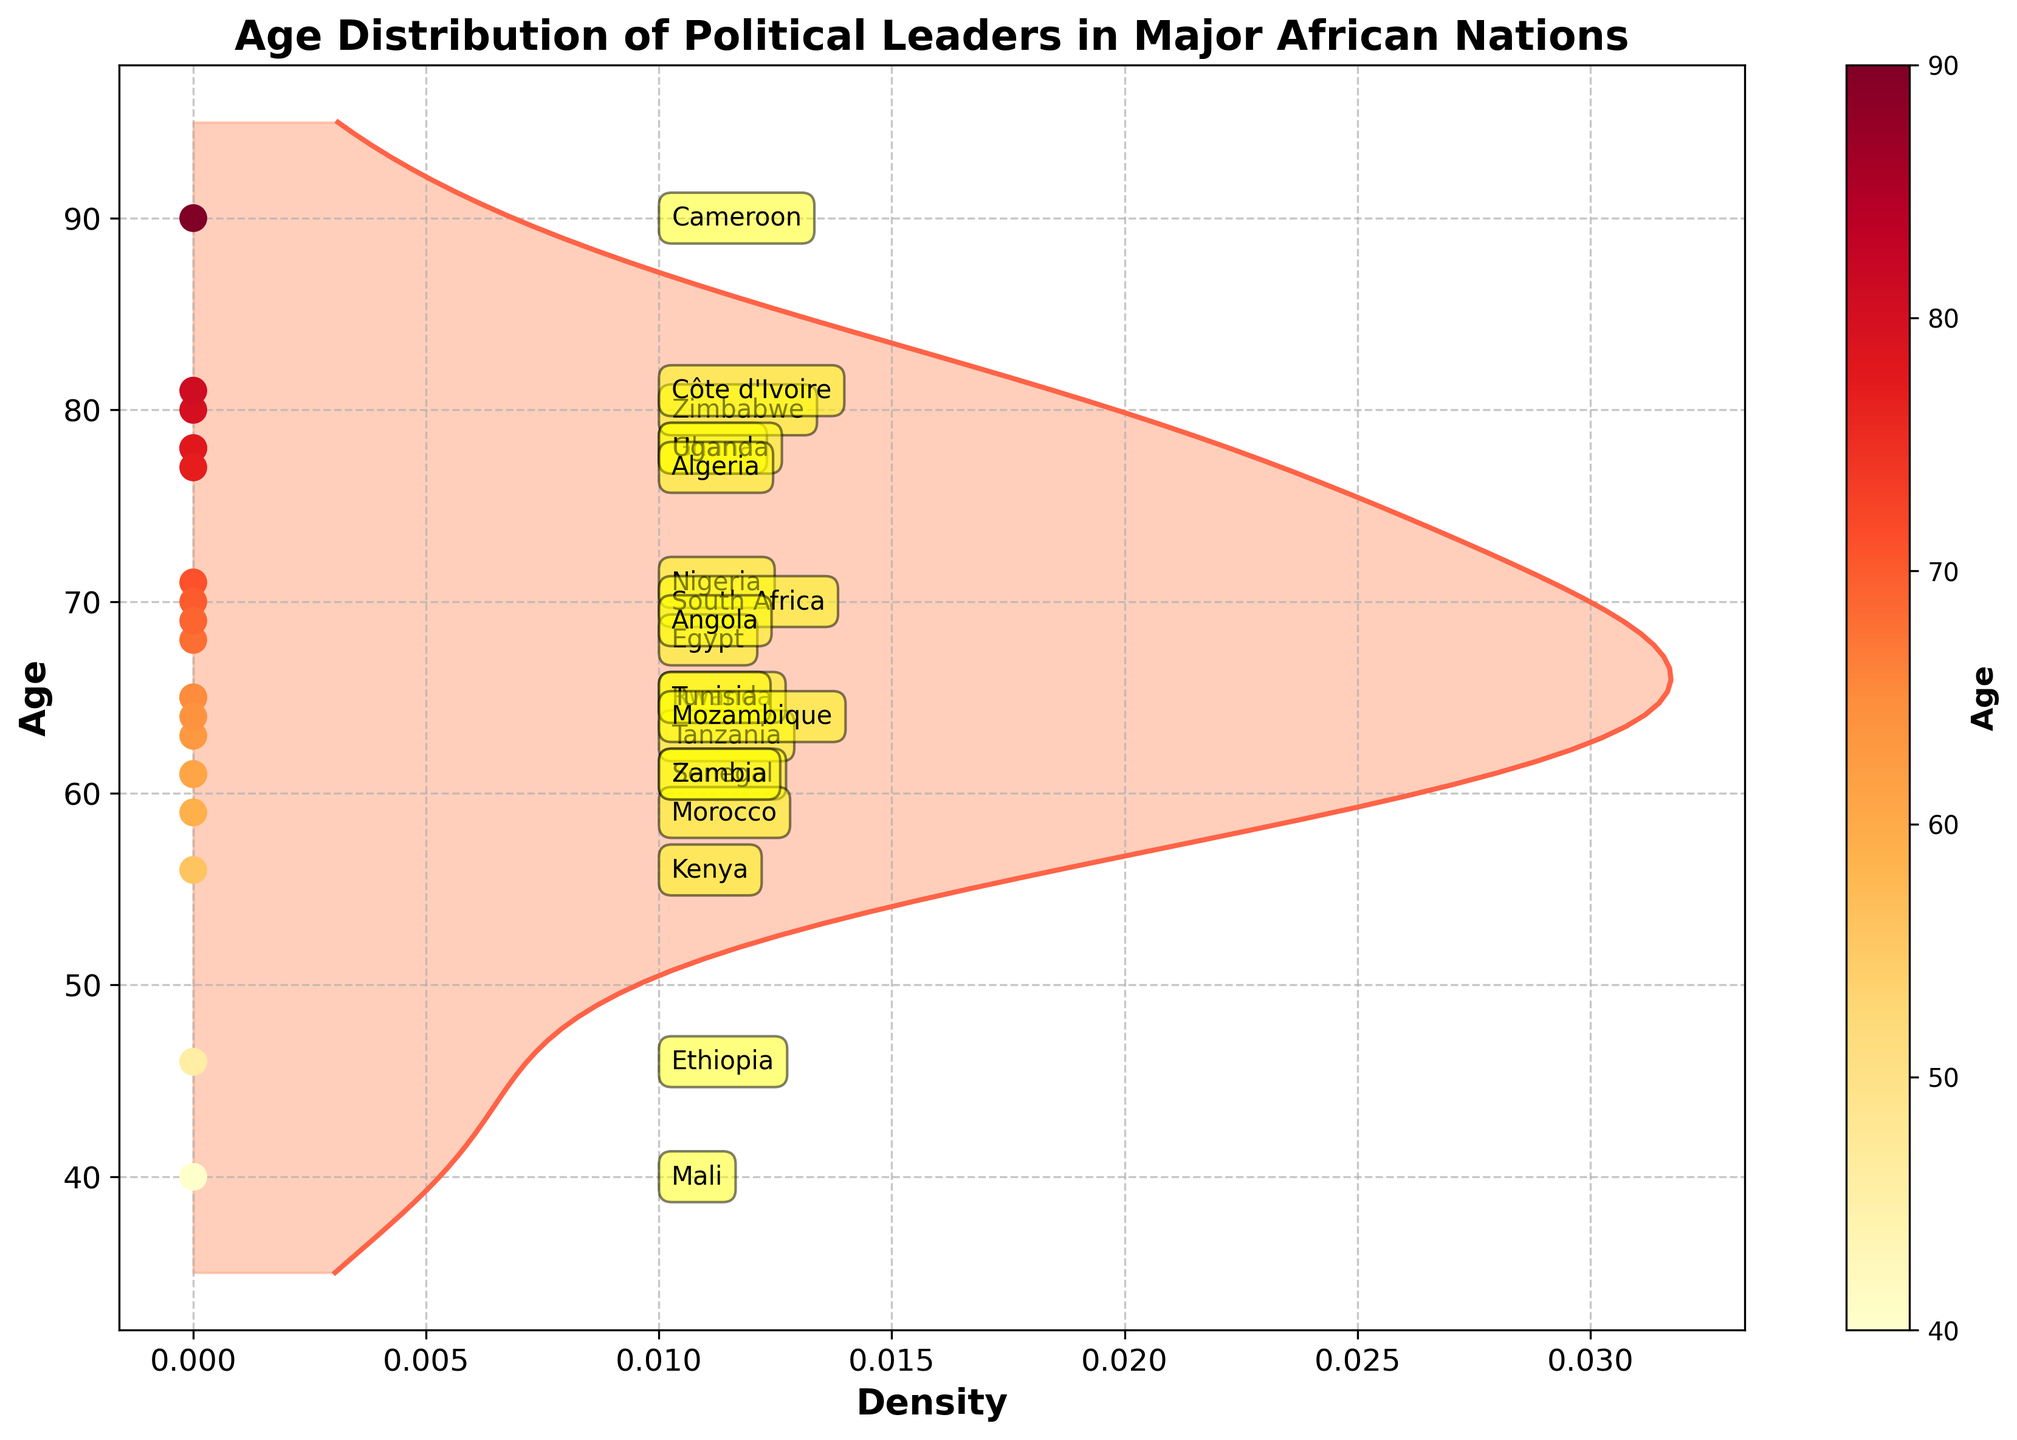What is the title of the figure? The title of the figure is usually located at the top and is in larger, bold font. It directly describes what the figure is about.
Answer: Age Distribution of Political Leaders in Major African Nations What are the x-axis and y-axis labels? The x-axis label is placed along the horizontal axis and indicates what the x values represent, while the y-axis label is along the vertical axis indicating what the y values represent.
Answer: x-axis: Density, y-axis: Age How many countries are represented in the figure? Count the number of unique data labels (country names) placed along the y-axis by the scatter points or annotations.
Answer: 20 Which country’s leader has the highest age, and what is that age? Look for the scatter point with the highest age value on the y-axis and identify its corresponding country through the annotation.
Answer: Cameroon, 90 How many political leaders are older than 70 years? Identify the scatter points with ages greater than 70 by referring to the y-axis, then count these points.
Answer: 8 Which country’s leader has the lowest age, and what is that age? Locate the scatter point with the lowest position on the y-axis and find its corresponding country through the annotation.
Answer: Mali, 40 What is the average age of the political leaders? Sum the ages of all the political leaders and divide by the total number of countries to calculate the average age. \[ (71 + 70 + 56 + 46 + 78 + 68 + 80 + 63 + 78 + 61 + 65 + 90 + 81 + 77 + 59 + 65 + 64 + 69 + 40 + 61)/20 = 67.4 \]
Answer: 67.4 Compare the density of ages around 60 and 80. Which age range has a higher density? Look at the density plot values for both age ranges and compare their height. Higher density corresponds to a taller curve.
Answer: Around 60 Which age group (under 50, 50-70, above 70) has the most political leaders? Categorize the scatter points into these age groups and count the number of leaders in each group.
Answer: 50-70 Which country leaders fall into the 60-70 age range? Look at scatter points within the y-axis range of 60 to 70 and read the corresponding country annotations.
Answer: South Africa, Egypt, Angola, Tanzania, Tunisia, Zambia 